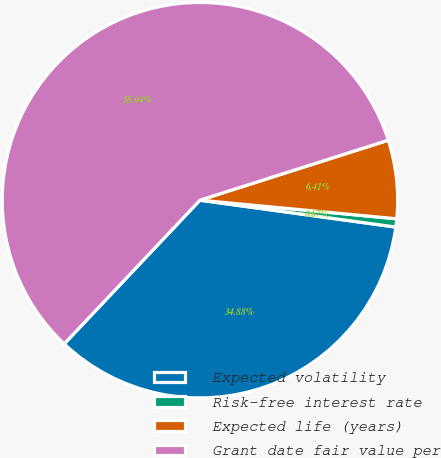Convert chart to OTSL. <chart><loc_0><loc_0><loc_500><loc_500><pie_chart><fcel>Expected volatility<fcel>Risk-free interest rate<fcel>Expected life (years)<fcel>Grant date fair value per<nl><fcel>34.88%<fcel>0.67%<fcel>6.41%<fcel>58.05%<nl></chart> 